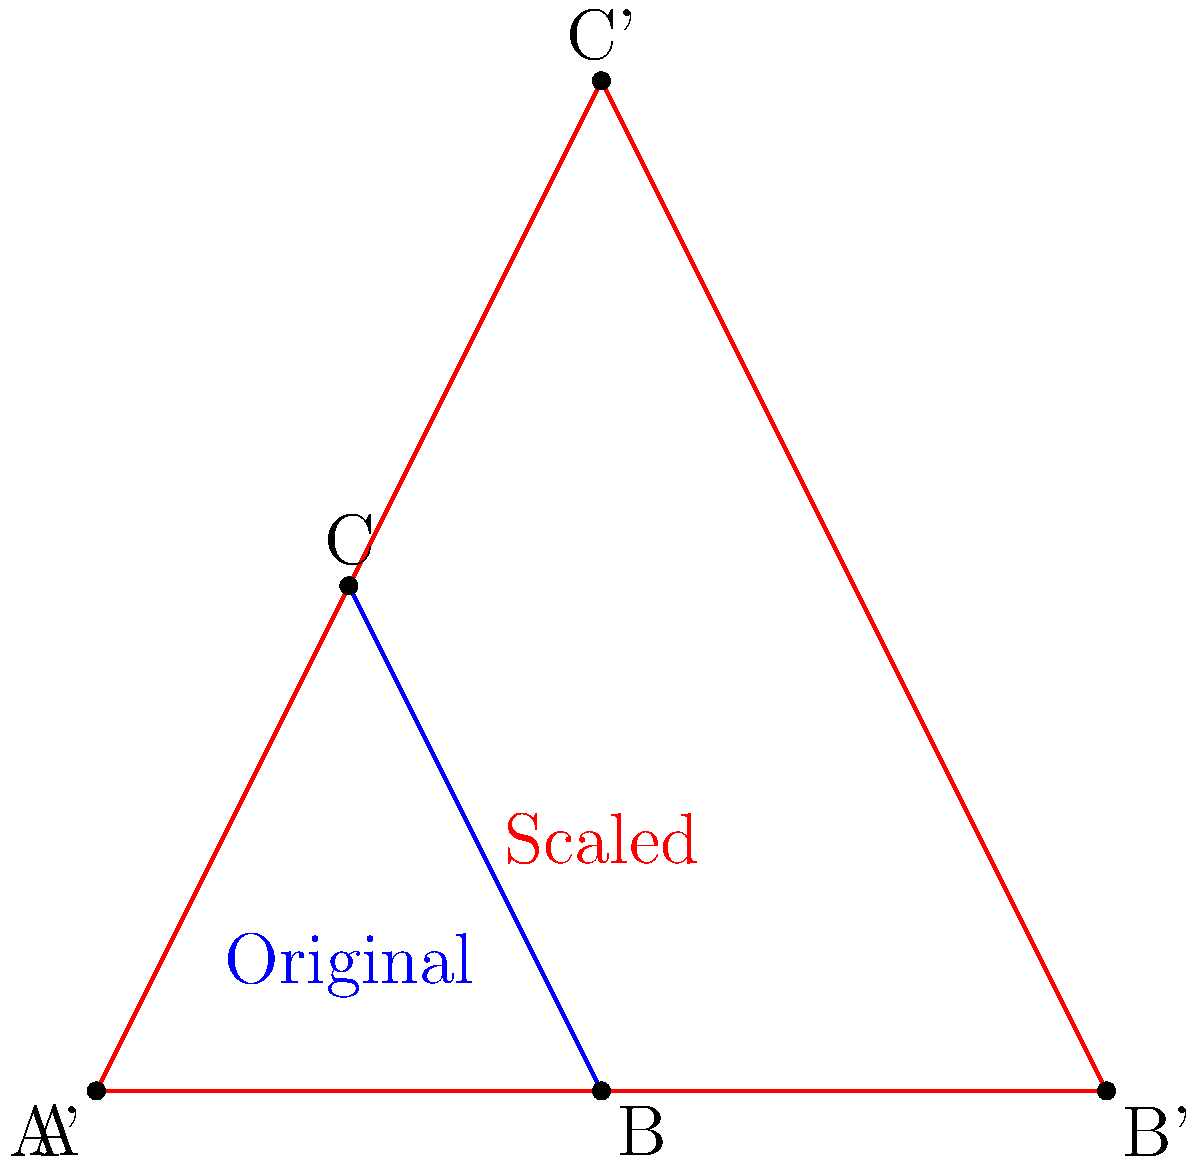Your child with Down syndrome is learning about shapes and sizes. To help them understand scaling, you show them two triangles: a blue one and a larger red one. The red triangle is a scaled version of the blue triangle. If the blue triangle has an area of 2 square units, what is the area of the red triangle? Let's approach this step-by-step:

1) First, we need to understand what scaling means. When we scale a shape, we multiply all its dimensions by the same factor.

2) Looking at the image, we can see that the red triangle is larger than the blue one. It appears that each side of the red triangle is twice as long as the corresponding side of the blue triangle.

3) This means the scale factor is 2. Every length in the red triangle is 2 times the corresponding length in the blue triangle.

4) Now, let's consider how scaling affects area. When we scale a 2D shape, the area doesn't just double when we double the side lengths. It actually increases by the square of the scale factor.

5) We can express this mathematically:
   New Area = (Scale Factor)² × Original Area

6) In this case:
   Scale Factor = 2
   Original Area = 2 square units

7) So, we can calculate:
   New Area = 2² × 2 = 4 × 2 = 8 square units

Therefore, the area of the red triangle is 8 square units.
Answer: 8 square units 